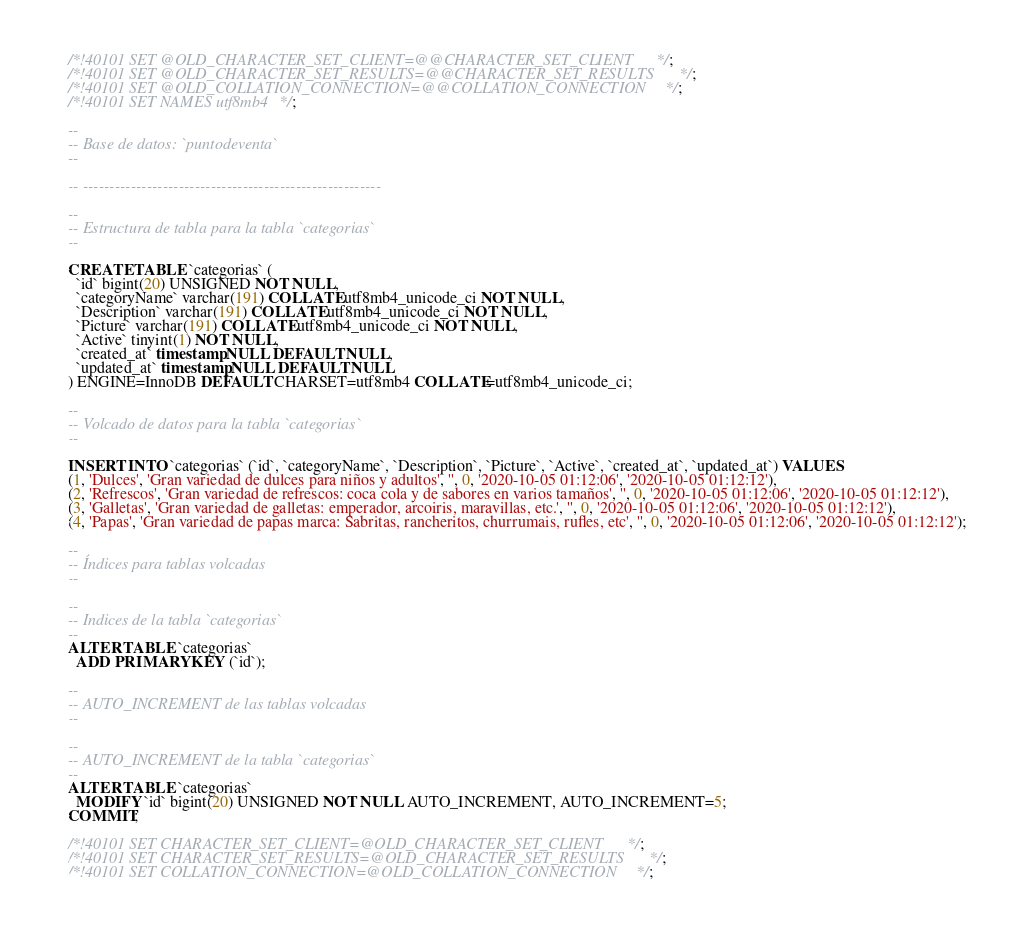Convert code to text. <code><loc_0><loc_0><loc_500><loc_500><_SQL_>

/*!40101 SET @OLD_CHARACTER_SET_CLIENT=@@CHARACTER_SET_CLIENT */;
/*!40101 SET @OLD_CHARACTER_SET_RESULTS=@@CHARACTER_SET_RESULTS */;
/*!40101 SET @OLD_COLLATION_CONNECTION=@@COLLATION_CONNECTION */;
/*!40101 SET NAMES utf8mb4 */;

--
-- Base de datos: `puntodeventa`
--

-- --------------------------------------------------------

--
-- Estructura de tabla para la tabla `categorias`
--

CREATE TABLE `categorias` (
  `id` bigint(20) UNSIGNED NOT NULL,
  `categoryName` varchar(191) COLLATE utf8mb4_unicode_ci NOT NULL,
  `Description` varchar(191) COLLATE utf8mb4_unicode_ci NOT NULL,
  `Picture` varchar(191) COLLATE utf8mb4_unicode_ci NOT NULL,
  `Active` tinyint(1) NOT NULL,
  `created_at` timestamp NULL DEFAULT NULL,
  `updated_at` timestamp NULL DEFAULT NULL
) ENGINE=InnoDB DEFAULT CHARSET=utf8mb4 COLLATE=utf8mb4_unicode_ci;

--
-- Volcado de datos para la tabla `categorias`
--

INSERT INTO `categorias` (`id`, `categoryName`, `Description`, `Picture`, `Active`, `created_at`, `updated_at`) VALUES
(1, 'Dulces', 'Gran variedad de dulces para niños y adultos', '', 0, '2020-10-05 01:12:06', '2020-10-05 01:12:12'),
(2, 'Refrescos', 'Gran variedad de refrescos: coca cola y de sabores en varios tamaños', '', 0, '2020-10-05 01:12:06', '2020-10-05 01:12:12'),
(3, 'Galletas', 'Gran variedad de galletas: emperador, arcoiris, maravillas, etc.', '', 0, '2020-10-05 01:12:06', '2020-10-05 01:12:12'),
(4, 'Papas', 'Gran variedad de papas marca: Sabritas, rancheritos, churrumais, rufles, etc', '', 0, '2020-10-05 01:12:06', '2020-10-05 01:12:12');

--
-- Índices para tablas volcadas
--

--
-- Indices de la tabla `categorias`
--
ALTER TABLE `categorias`
  ADD PRIMARY KEY (`id`);

--
-- AUTO_INCREMENT de las tablas volcadas
--

--
-- AUTO_INCREMENT de la tabla `categorias`
--
ALTER TABLE `categorias`
  MODIFY `id` bigint(20) UNSIGNED NOT NULL AUTO_INCREMENT, AUTO_INCREMENT=5;
COMMIT;

/*!40101 SET CHARACTER_SET_CLIENT=@OLD_CHARACTER_SET_CLIENT */;
/*!40101 SET CHARACTER_SET_RESULTS=@OLD_CHARACTER_SET_RESULTS */;
/*!40101 SET COLLATION_CONNECTION=@OLD_COLLATION_CONNECTION */;
</code> 